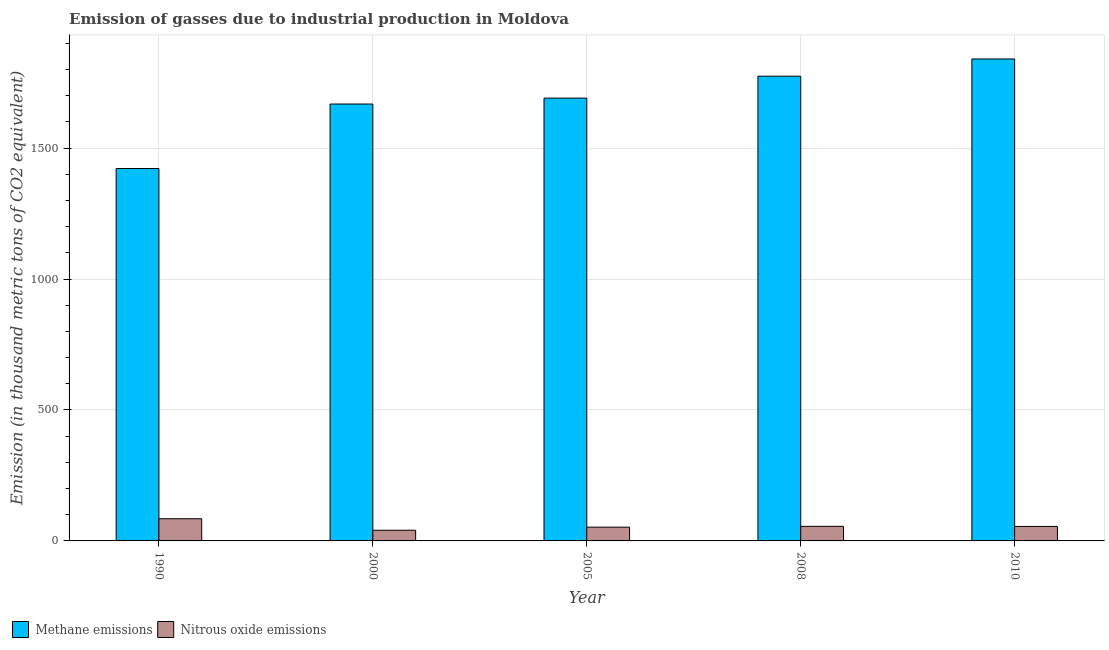Are the number of bars on each tick of the X-axis equal?
Offer a terse response. Yes. What is the label of the 5th group of bars from the left?
Make the answer very short. 2010. In how many cases, is the number of bars for a given year not equal to the number of legend labels?
Give a very brief answer. 0. What is the amount of nitrous oxide emissions in 2008?
Offer a terse response. 55.7. Across all years, what is the maximum amount of nitrous oxide emissions?
Your answer should be very brief. 84.7. Across all years, what is the minimum amount of nitrous oxide emissions?
Offer a very short reply. 40.8. What is the total amount of methane emissions in the graph?
Keep it short and to the point. 8397.3. What is the difference between the amount of methane emissions in 2000 and that in 2005?
Ensure brevity in your answer.  -22.6. What is the difference between the amount of nitrous oxide emissions in 2000 and the amount of methane emissions in 2005?
Provide a short and direct response. -11.8. What is the average amount of methane emissions per year?
Offer a very short reply. 1679.46. In the year 2008, what is the difference between the amount of nitrous oxide emissions and amount of methane emissions?
Offer a very short reply. 0. What is the ratio of the amount of methane emissions in 2005 to that in 2010?
Make the answer very short. 0.92. What is the difference between the highest and the lowest amount of methane emissions?
Offer a terse response. 418.3. In how many years, is the amount of methane emissions greater than the average amount of methane emissions taken over all years?
Make the answer very short. 3. Is the sum of the amount of nitrous oxide emissions in 2008 and 2010 greater than the maximum amount of methane emissions across all years?
Keep it short and to the point. Yes. What does the 2nd bar from the left in 2000 represents?
Your response must be concise. Nitrous oxide emissions. What does the 1st bar from the right in 2000 represents?
Make the answer very short. Nitrous oxide emissions. How many years are there in the graph?
Your answer should be very brief. 5. Are the values on the major ticks of Y-axis written in scientific E-notation?
Offer a terse response. No. Does the graph contain any zero values?
Offer a very short reply. No. Where does the legend appear in the graph?
Ensure brevity in your answer.  Bottom left. How are the legend labels stacked?
Offer a terse response. Horizontal. What is the title of the graph?
Keep it short and to the point. Emission of gasses due to industrial production in Moldova. Does "Broad money growth" appear as one of the legend labels in the graph?
Keep it short and to the point. No. What is the label or title of the X-axis?
Ensure brevity in your answer.  Year. What is the label or title of the Y-axis?
Keep it short and to the point. Emission (in thousand metric tons of CO2 equivalent). What is the Emission (in thousand metric tons of CO2 equivalent) in Methane emissions in 1990?
Your answer should be compact. 1422.3. What is the Emission (in thousand metric tons of CO2 equivalent) in Nitrous oxide emissions in 1990?
Provide a short and direct response. 84.7. What is the Emission (in thousand metric tons of CO2 equivalent) in Methane emissions in 2000?
Give a very brief answer. 1668.5. What is the Emission (in thousand metric tons of CO2 equivalent) in Nitrous oxide emissions in 2000?
Your answer should be compact. 40.8. What is the Emission (in thousand metric tons of CO2 equivalent) of Methane emissions in 2005?
Provide a short and direct response. 1691.1. What is the Emission (in thousand metric tons of CO2 equivalent) in Nitrous oxide emissions in 2005?
Provide a short and direct response. 52.6. What is the Emission (in thousand metric tons of CO2 equivalent) of Methane emissions in 2008?
Your answer should be compact. 1774.8. What is the Emission (in thousand metric tons of CO2 equivalent) in Nitrous oxide emissions in 2008?
Offer a very short reply. 55.7. What is the Emission (in thousand metric tons of CO2 equivalent) in Methane emissions in 2010?
Your response must be concise. 1840.6. What is the Emission (in thousand metric tons of CO2 equivalent) in Nitrous oxide emissions in 2010?
Ensure brevity in your answer.  55.3. Across all years, what is the maximum Emission (in thousand metric tons of CO2 equivalent) in Methane emissions?
Your answer should be compact. 1840.6. Across all years, what is the maximum Emission (in thousand metric tons of CO2 equivalent) in Nitrous oxide emissions?
Give a very brief answer. 84.7. Across all years, what is the minimum Emission (in thousand metric tons of CO2 equivalent) of Methane emissions?
Keep it short and to the point. 1422.3. Across all years, what is the minimum Emission (in thousand metric tons of CO2 equivalent) of Nitrous oxide emissions?
Offer a very short reply. 40.8. What is the total Emission (in thousand metric tons of CO2 equivalent) in Methane emissions in the graph?
Ensure brevity in your answer.  8397.3. What is the total Emission (in thousand metric tons of CO2 equivalent) of Nitrous oxide emissions in the graph?
Your response must be concise. 289.1. What is the difference between the Emission (in thousand metric tons of CO2 equivalent) in Methane emissions in 1990 and that in 2000?
Your answer should be compact. -246.2. What is the difference between the Emission (in thousand metric tons of CO2 equivalent) of Nitrous oxide emissions in 1990 and that in 2000?
Ensure brevity in your answer.  43.9. What is the difference between the Emission (in thousand metric tons of CO2 equivalent) in Methane emissions in 1990 and that in 2005?
Ensure brevity in your answer.  -268.8. What is the difference between the Emission (in thousand metric tons of CO2 equivalent) in Nitrous oxide emissions in 1990 and that in 2005?
Give a very brief answer. 32.1. What is the difference between the Emission (in thousand metric tons of CO2 equivalent) in Methane emissions in 1990 and that in 2008?
Offer a very short reply. -352.5. What is the difference between the Emission (in thousand metric tons of CO2 equivalent) of Methane emissions in 1990 and that in 2010?
Your answer should be compact. -418.3. What is the difference between the Emission (in thousand metric tons of CO2 equivalent) in Nitrous oxide emissions in 1990 and that in 2010?
Your response must be concise. 29.4. What is the difference between the Emission (in thousand metric tons of CO2 equivalent) in Methane emissions in 2000 and that in 2005?
Keep it short and to the point. -22.6. What is the difference between the Emission (in thousand metric tons of CO2 equivalent) of Nitrous oxide emissions in 2000 and that in 2005?
Your answer should be very brief. -11.8. What is the difference between the Emission (in thousand metric tons of CO2 equivalent) of Methane emissions in 2000 and that in 2008?
Give a very brief answer. -106.3. What is the difference between the Emission (in thousand metric tons of CO2 equivalent) of Nitrous oxide emissions in 2000 and that in 2008?
Keep it short and to the point. -14.9. What is the difference between the Emission (in thousand metric tons of CO2 equivalent) of Methane emissions in 2000 and that in 2010?
Offer a terse response. -172.1. What is the difference between the Emission (in thousand metric tons of CO2 equivalent) in Methane emissions in 2005 and that in 2008?
Keep it short and to the point. -83.7. What is the difference between the Emission (in thousand metric tons of CO2 equivalent) in Nitrous oxide emissions in 2005 and that in 2008?
Offer a very short reply. -3.1. What is the difference between the Emission (in thousand metric tons of CO2 equivalent) of Methane emissions in 2005 and that in 2010?
Offer a very short reply. -149.5. What is the difference between the Emission (in thousand metric tons of CO2 equivalent) of Nitrous oxide emissions in 2005 and that in 2010?
Ensure brevity in your answer.  -2.7. What is the difference between the Emission (in thousand metric tons of CO2 equivalent) of Methane emissions in 2008 and that in 2010?
Give a very brief answer. -65.8. What is the difference between the Emission (in thousand metric tons of CO2 equivalent) in Methane emissions in 1990 and the Emission (in thousand metric tons of CO2 equivalent) in Nitrous oxide emissions in 2000?
Keep it short and to the point. 1381.5. What is the difference between the Emission (in thousand metric tons of CO2 equivalent) in Methane emissions in 1990 and the Emission (in thousand metric tons of CO2 equivalent) in Nitrous oxide emissions in 2005?
Keep it short and to the point. 1369.7. What is the difference between the Emission (in thousand metric tons of CO2 equivalent) of Methane emissions in 1990 and the Emission (in thousand metric tons of CO2 equivalent) of Nitrous oxide emissions in 2008?
Keep it short and to the point. 1366.6. What is the difference between the Emission (in thousand metric tons of CO2 equivalent) of Methane emissions in 1990 and the Emission (in thousand metric tons of CO2 equivalent) of Nitrous oxide emissions in 2010?
Your response must be concise. 1367. What is the difference between the Emission (in thousand metric tons of CO2 equivalent) of Methane emissions in 2000 and the Emission (in thousand metric tons of CO2 equivalent) of Nitrous oxide emissions in 2005?
Make the answer very short. 1615.9. What is the difference between the Emission (in thousand metric tons of CO2 equivalent) in Methane emissions in 2000 and the Emission (in thousand metric tons of CO2 equivalent) in Nitrous oxide emissions in 2008?
Your answer should be very brief. 1612.8. What is the difference between the Emission (in thousand metric tons of CO2 equivalent) in Methane emissions in 2000 and the Emission (in thousand metric tons of CO2 equivalent) in Nitrous oxide emissions in 2010?
Make the answer very short. 1613.2. What is the difference between the Emission (in thousand metric tons of CO2 equivalent) in Methane emissions in 2005 and the Emission (in thousand metric tons of CO2 equivalent) in Nitrous oxide emissions in 2008?
Give a very brief answer. 1635.4. What is the difference between the Emission (in thousand metric tons of CO2 equivalent) in Methane emissions in 2005 and the Emission (in thousand metric tons of CO2 equivalent) in Nitrous oxide emissions in 2010?
Offer a terse response. 1635.8. What is the difference between the Emission (in thousand metric tons of CO2 equivalent) of Methane emissions in 2008 and the Emission (in thousand metric tons of CO2 equivalent) of Nitrous oxide emissions in 2010?
Offer a terse response. 1719.5. What is the average Emission (in thousand metric tons of CO2 equivalent) of Methane emissions per year?
Make the answer very short. 1679.46. What is the average Emission (in thousand metric tons of CO2 equivalent) of Nitrous oxide emissions per year?
Your answer should be compact. 57.82. In the year 1990, what is the difference between the Emission (in thousand metric tons of CO2 equivalent) in Methane emissions and Emission (in thousand metric tons of CO2 equivalent) in Nitrous oxide emissions?
Offer a terse response. 1337.6. In the year 2000, what is the difference between the Emission (in thousand metric tons of CO2 equivalent) in Methane emissions and Emission (in thousand metric tons of CO2 equivalent) in Nitrous oxide emissions?
Make the answer very short. 1627.7. In the year 2005, what is the difference between the Emission (in thousand metric tons of CO2 equivalent) of Methane emissions and Emission (in thousand metric tons of CO2 equivalent) of Nitrous oxide emissions?
Make the answer very short. 1638.5. In the year 2008, what is the difference between the Emission (in thousand metric tons of CO2 equivalent) of Methane emissions and Emission (in thousand metric tons of CO2 equivalent) of Nitrous oxide emissions?
Make the answer very short. 1719.1. In the year 2010, what is the difference between the Emission (in thousand metric tons of CO2 equivalent) in Methane emissions and Emission (in thousand metric tons of CO2 equivalent) in Nitrous oxide emissions?
Provide a succinct answer. 1785.3. What is the ratio of the Emission (in thousand metric tons of CO2 equivalent) of Methane emissions in 1990 to that in 2000?
Your answer should be compact. 0.85. What is the ratio of the Emission (in thousand metric tons of CO2 equivalent) in Nitrous oxide emissions in 1990 to that in 2000?
Your response must be concise. 2.08. What is the ratio of the Emission (in thousand metric tons of CO2 equivalent) in Methane emissions in 1990 to that in 2005?
Give a very brief answer. 0.84. What is the ratio of the Emission (in thousand metric tons of CO2 equivalent) of Nitrous oxide emissions in 1990 to that in 2005?
Keep it short and to the point. 1.61. What is the ratio of the Emission (in thousand metric tons of CO2 equivalent) in Methane emissions in 1990 to that in 2008?
Your answer should be compact. 0.8. What is the ratio of the Emission (in thousand metric tons of CO2 equivalent) of Nitrous oxide emissions in 1990 to that in 2008?
Provide a succinct answer. 1.52. What is the ratio of the Emission (in thousand metric tons of CO2 equivalent) in Methane emissions in 1990 to that in 2010?
Give a very brief answer. 0.77. What is the ratio of the Emission (in thousand metric tons of CO2 equivalent) of Nitrous oxide emissions in 1990 to that in 2010?
Provide a short and direct response. 1.53. What is the ratio of the Emission (in thousand metric tons of CO2 equivalent) of Methane emissions in 2000 to that in 2005?
Keep it short and to the point. 0.99. What is the ratio of the Emission (in thousand metric tons of CO2 equivalent) in Nitrous oxide emissions in 2000 to that in 2005?
Provide a succinct answer. 0.78. What is the ratio of the Emission (in thousand metric tons of CO2 equivalent) of Methane emissions in 2000 to that in 2008?
Offer a terse response. 0.94. What is the ratio of the Emission (in thousand metric tons of CO2 equivalent) of Nitrous oxide emissions in 2000 to that in 2008?
Your answer should be compact. 0.73. What is the ratio of the Emission (in thousand metric tons of CO2 equivalent) of Methane emissions in 2000 to that in 2010?
Offer a very short reply. 0.91. What is the ratio of the Emission (in thousand metric tons of CO2 equivalent) of Nitrous oxide emissions in 2000 to that in 2010?
Your answer should be very brief. 0.74. What is the ratio of the Emission (in thousand metric tons of CO2 equivalent) in Methane emissions in 2005 to that in 2008?
Provide a succinct answer. 0.95. What is the ratio of the Emission (in thousand metric tons of CO2 equivalent) in Nitrous oxide emissions in 2005 to that in 2008?
Give a very brief answer. 0.94. What is the ratio of the Emission (in thousand metric tons of CO2 equivalent) in Methane emissions in 2005 to that in 2010?
Your response must be concise. 0.92. What is the ratio of the Emission (in thousand metric tons of CO2 equivalent) of Nitrous oxide emissions in 2005 to that in 2010?
Your answer should be very brief. 0.95. What is the ratio of the Emission (in thousand metric tons of CO2 equivalent) in Methane emissions in 2008 to that in 2010?
Keep it short and to the point. 0.96. What is the ratio of the Emission (in thousand metric tons of CO2 equivalent) in Nitrous oxide emissions in 2008 to that in 2010?
Offer a terse response. 1.01. What is the difference between the highest and the second highest Emission (in thousand metric tons of CO2 equivalent) of Methane emissions?
Give a very brief answer. 65.8. What is the difference between the highest and the lowest Emission (in thousand metric tons of CO2 equivalent) in Methane emissions?
Your answer should be compact. 418.3. What is the difference between the highest and the lowest Emission (in thousand metric tons of CO2 equivalent) in Nitrous oxide emissions?
Give a very brief answer. 43.9. 